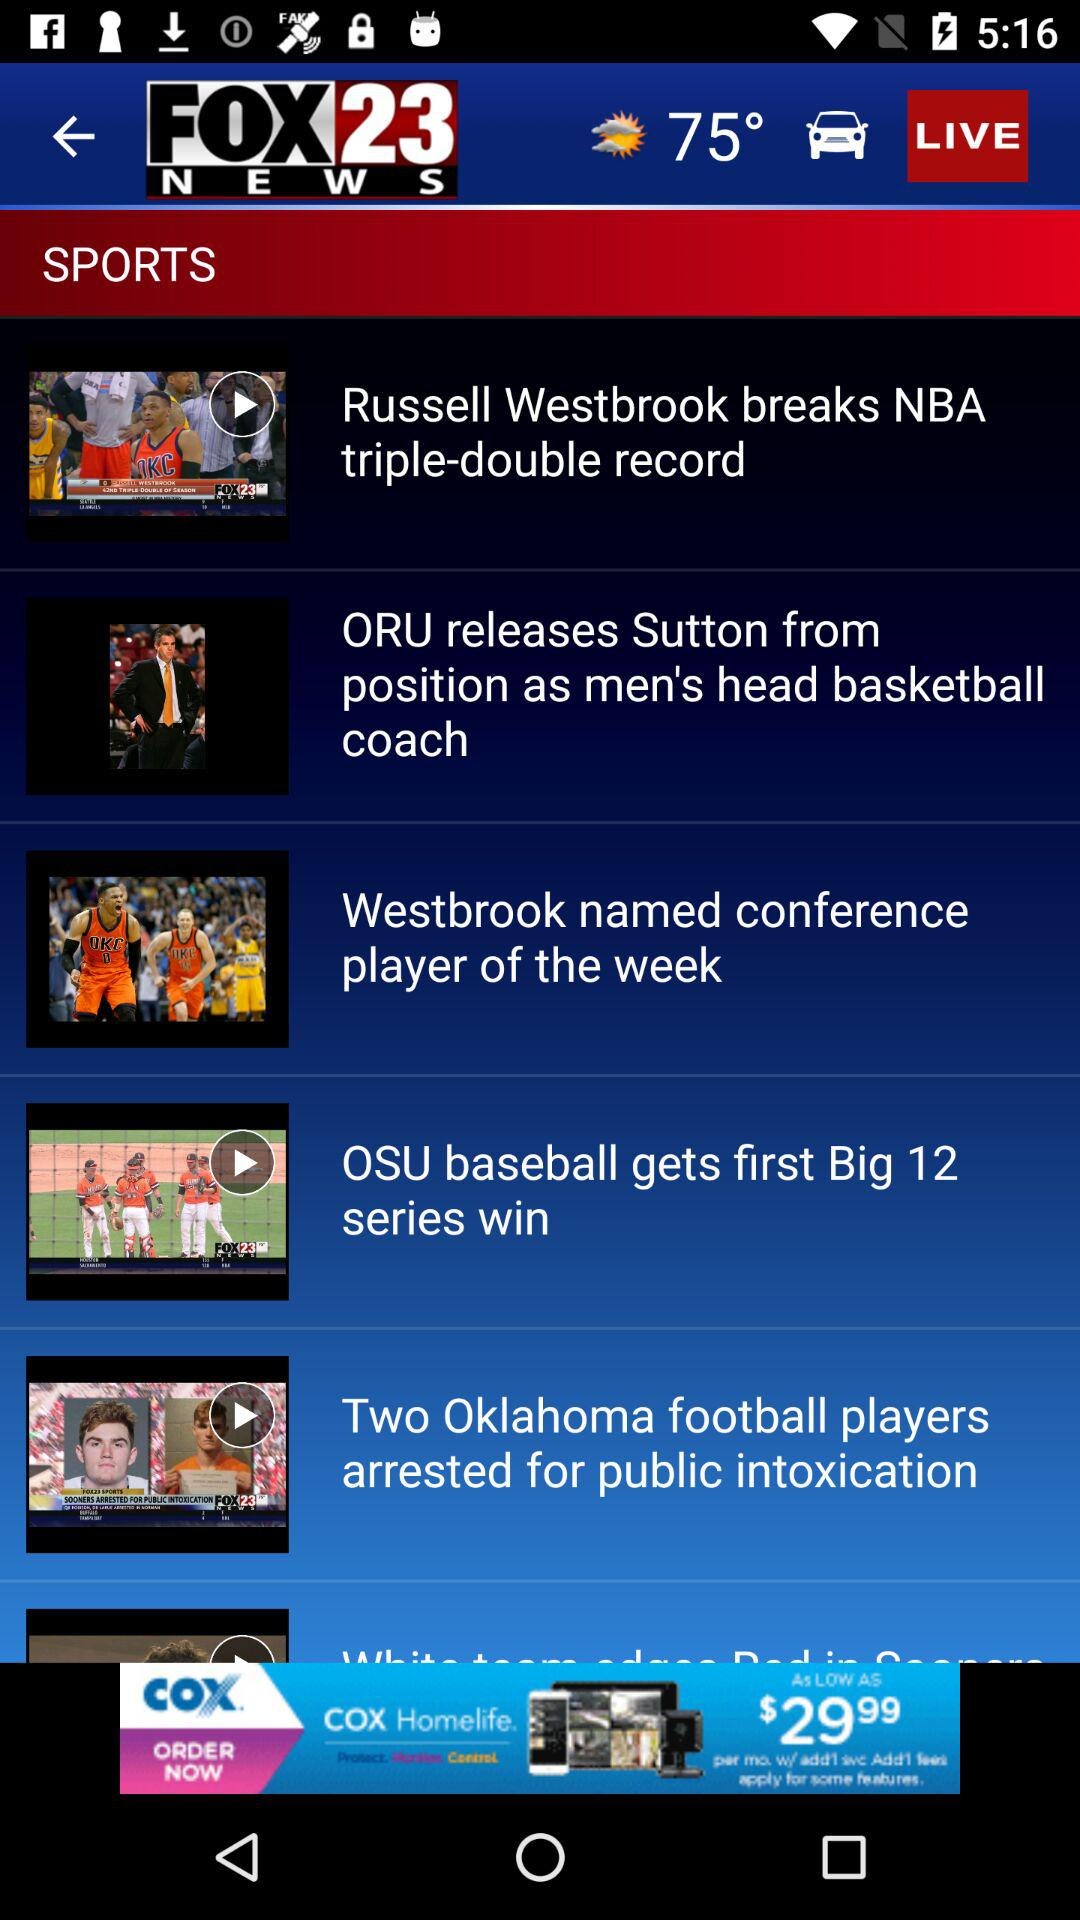What is the temperature? The temperature is 75°. 